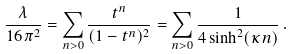Convert formula to latex. <formula><loc_0><loc_0><loc_500><loc_500>\frac { \lambda } { 1 6 \pi ^ { 2 } } = \sum _ { n > 0 } \frac { t ^ { n } } { ( 1 - t ^ { n } ) ^ { 2 } } = \sum _ { n > 0 } \frac { 1 } { 4 \sinh ^ { 2 } ( \kappa n ) } \, .</formula> 